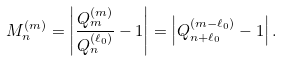<formula> <loc_0><loc_0><loc_500><loc_500>M _ { n } ^ { ( m ) } = \left | \frac { Q _ { m } ^ { ( m ) } } { Q _ { n } ^ { ( \ell _ { 0 } ) } } - 1 \right | = \left | Q _ { n + \ell _ { 0 } } ^ { ( m - \ell _ { 0 } ) } - 1 \right | .</formula> 